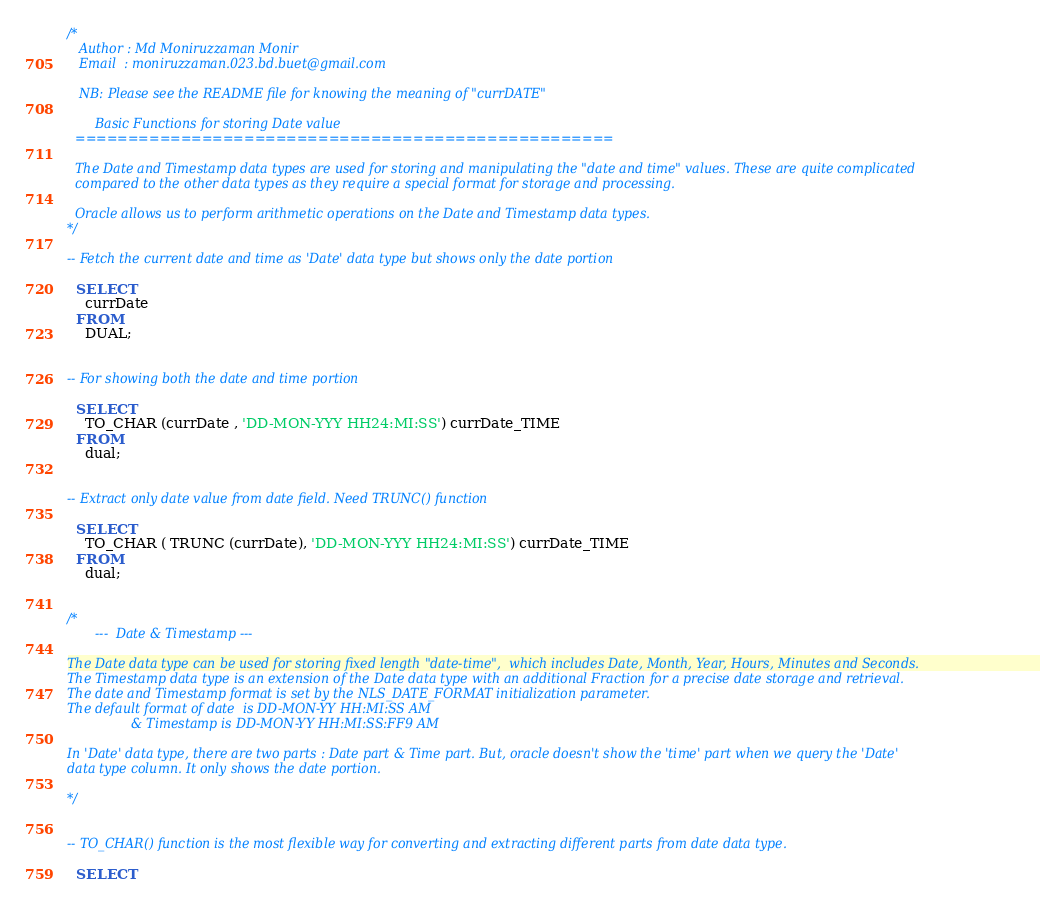Convert code to text. <code><loc_0><loc_0><loc_500><loc_500><_SQL_>/*
   Author : Md Moniruzzaman Monir
   Email  : moniruzzaman.023.bd.buet@gmail.com

   NB: Please see the README file for knowing the meaning of "currDATE"

       Basic Functions for storing Date value
  ===================================================
  
  The Date and Timestamp data types are used for storing and manipulating the "date and time" values. These are quite complicated 
  compared to the other data types as they require a special format for storage and processing.
  
  Oracle allows us to perform arithmetic operations on the Date and Timestamp data types.
*/
    
-- Fetch the current date and time as 'Date' data type but shows only the date portion

  SELECT
    currDate 
  FROM
    DUAL; 
  

-- For showing both the date and time portion

  SELECT
    TO_CHAR (currDate , 'DD-MON-YYY HH24:MI:SS') currDate_TIME
  FROM
    dual;
  
  
-- Extract only date value from date field. Need TRUNC() function

  SELECT
    TO_CHAR ( TRUNC (currDate), 'DD-MON-YYY HH24:MI:SS') currDate_TIME
  FROM
    dual;


/*
       ---  Date & Timestamp ---
       
The Date data type can be used for storing fixed length "date-time",  which includes Date, Month, Year, Hours, Minutes and Seconds.
The Timestamp data type is an extension of the Date data type with an additional Fraction for a precise date storage and retrieval.
The date and Timestamp format is set by the NLS_DATE_FORMAT initialization parameter. 
The default format of date  is DD-MON-YY HH:MI:SS AM  
                & Timestamp is DD-MON-YY HH:MI:SS:FF9 AM

In 'Date' data type, there are two parts : Date part & Time part. But, oracle doesn't show the 'time' part when we query the 'Date' 
data type column. It only shows the date portion.
  
*/


-- TO_CHAR() function is the most flexible way for converting and extracting different parts from date data type.

  SELECT</code> 